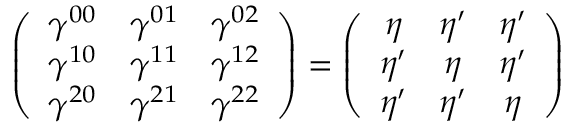Convert formula to latex. <formula><loc_0><loc_0><loc_500><loc_500>\left ( \begin{array} { c c c } { { \gamma ^ { 0 0 } } } & { { \gamma ^ { 0 1 } } } & { { \gamma ^ { 0 2 } } } \\ { { \gamma ^ { 1 0 } } } & { { \gamma ^ { 1 1 } } } & { { \gamma ^ { 1 2 } } } \\ { { \gamma ^ { 2 0 } } } & { { \gamma ^ { 2 1 } } } & { { \gamma ^ { 2 2 } } } \end{array} \right ) = \left ( \begin{array} { c c c } { \eta } & { { \eta ^ { \prime } } } & { { \eta ^ { \prime } } } \\ { { \eta ^ { \prime } } } & { \eta } & { { \eta ^ { \prime } } } \\ { { \eta ^ { \prime } } } & { { \eta ^ { \prime } } } & { \eta } \end{array} \right )</formula> 